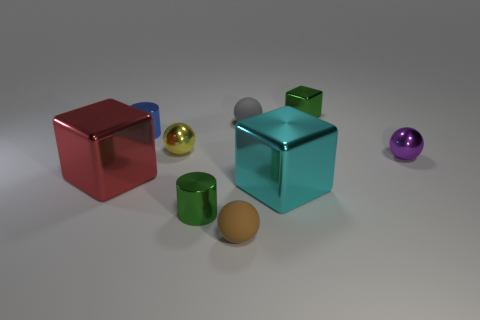The small sphere that is right of the tiny green shiny object that is behind the red shiny object is made of what material?
Offer a terse response. Metal. There is a yellow sphere; is it the same size as the metallic thing that is right of the green cube?
Ensure brevity in your answer.  Yes. What is the material of the big object behind the large cyan metal thing?
Provide a succinct answer. Metal. Is the yellow sphere the same size as the green cube?
Provide a short and direct response. Yes. There is a object to the left of the small metallic cylinder behind the tiny green metallic cylinder; what size is it?
Ensure brevity in your answer.  Large. What color is the block that is both behind the big cyan metallic thing and right of the large red metal block?
Provide a short and direct response. Green. Does the cyan metal object have the same shape as the red metal object?
Give a very brief answer. Yes. What shape is the big object that is on the right side of the cylinder that is to the left of the tiny green shiny cylinder?
Your answer should be compact. Cube. Does the small purple object have the same shape as the tiny green object in front of the purple metallic ball?
Offer a very short reply. No. There is a matte sphere that is the same size as the brown thing; what is its color?
Give a very brief answer. Gray. 